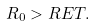Convert formula to latex. <formula><loc_0><loc_0><loc_500><loc_500>R _ { 0 } > R E T .</formula> 